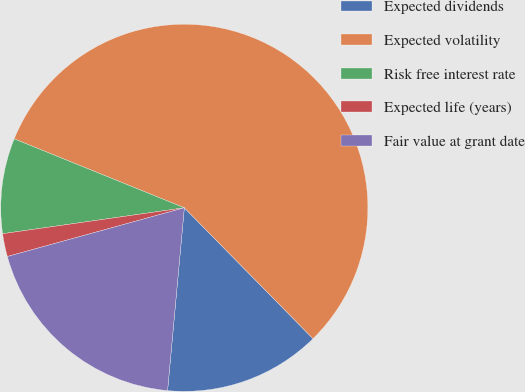Convert chart. <chart><loc_0><loc_0><loc_500><loc_500><pie_chart><fcel>Expected dividends<fcel>Expected volatility<fcel>Risk free interest rate<fcel>Expected life (years)<fcel>Fair value at grant date<nl><fcel>13.82%<fcel>56.51%<fcel>8.38%<fcel>2.02%<fcel>19.27%<nl></chart> 